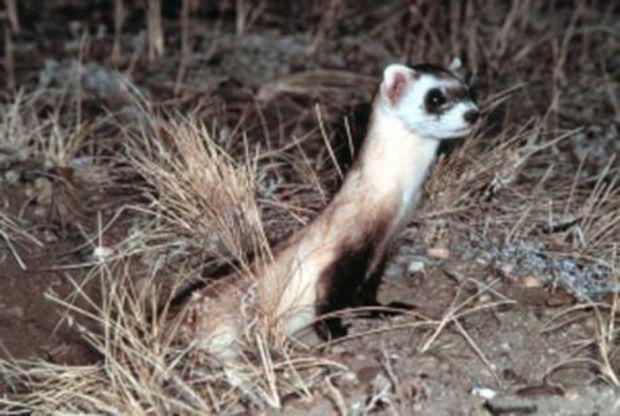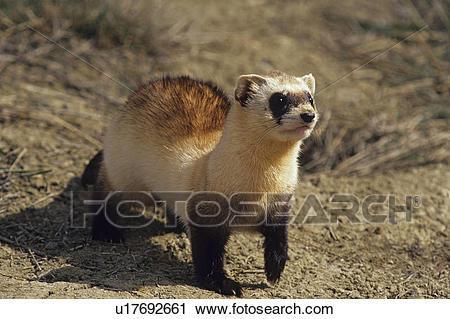The first image is the image on the left, the second image is the image on the right. Assess this claim about the two images: "The animal in the image on the left is emerging from its burrow.". Correct or not? Answer yes or no. Yes. 